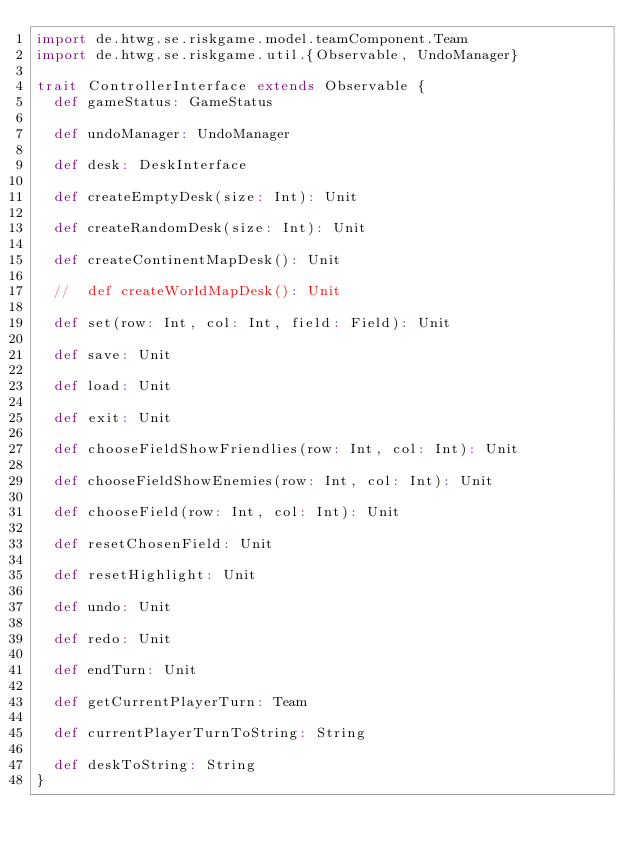Convert code to text. <code><loc_0><loc_0><loc_500><loc_500><_Scala_>import de.htwg.se.riskgame.model.teamComponent.Team
import de.htwg.se.riskgame.util.{Observable, UndoManager}

trait ControllerInterface extends Observable {
  def gameStatus: GameStatus

  def undoManager: UndoManager

  def desk: DeskInterface

  def createEmptyDesk(size: Int): Unit

  def createRandomDesk(size: Int): Unit

  def createContinentMapDesk(): Unit

  //  def createWorldMapDesk(): Unit

  def set(row: Int, col: Int, field: Field): Unit

  def save: Unit

  def load: Unit

  def exit: Unit

  def chooseFieldShowFriendlies(row: Int, col: Int): Unit

  def chooseFieldShowEnemies(row: Int, col: Int): Unit

  def chooseField(row: Int, col: Int): Unit

  def resetChosenField: Unit

  def resetHighlight: Unit

  def undo: Unit

  def redo: Unit

  def endTurn: Unit

  def getCurrentPlayerTurn: Team

  def currentPlayerTurnToString: String

  def deskToString: String
}
</code> 